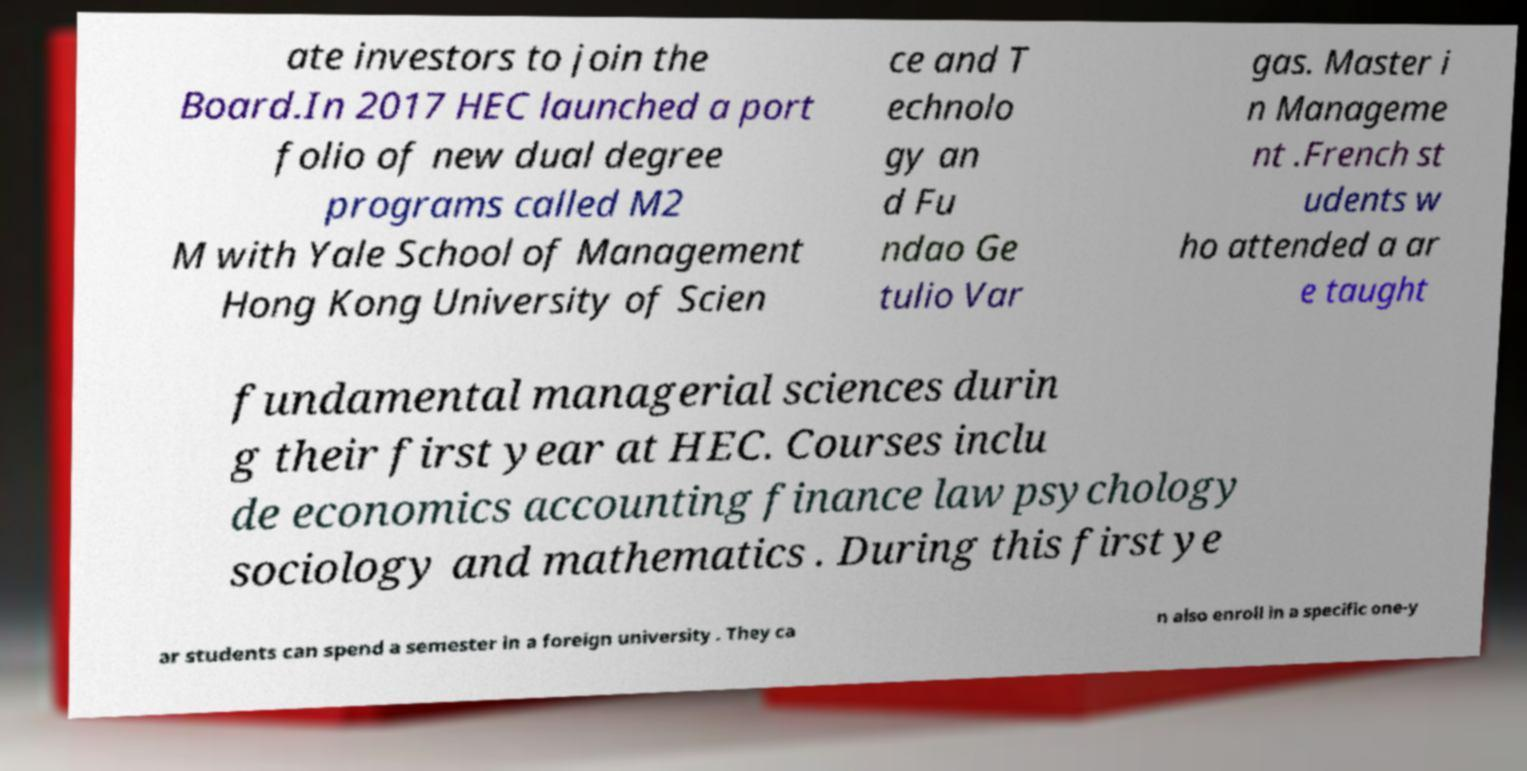Can you read and provide the text displayed in the image?This photo seems to have some interesting text. Can you extract and type it out for me? ate investors to join the Board.In 2017 HEC launched a port folio of new dual degree programs called M2 M with Yale School of Management Hong Kong University of Scien ce and T echnolo gy an d Fu ndao Ge tulio Var gas. Master i n Manageme nt .French st udents w ho attended a ar e taught fundamental managerial sciences durin g their first year at HEC. Courses inclu de economics accounting finance law psychology sociology and mathematics . During this first ye ar students can spend a semester in a foreign university . They ca n also enroll in a specific one-y 